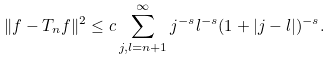Convert formula to latex. <formula><loc_0><loc_0><loc_500><loc_500>\| f - T _ { n } f \| ^ { 2 } \leq c \sum _ { j , l = n + 1 } ^ { \infty } j ^ { - s } l ^ { - s } ( 1 + | j - l | ) ^ { - s } .</formula> 